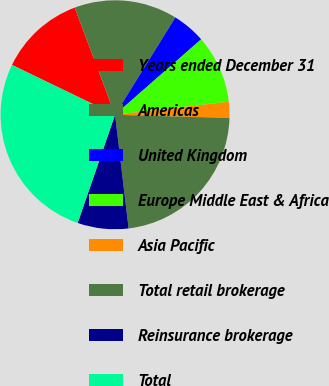Convert chart to OTSL. <chart><loc_0><loc_0><loc_500><loc_500><pie_chart><fcel>Years ended December 31<fcel>Americas<fcel>United Kingdom<fcel>Europe Middle East & Africa<fcel>Asia Pacific<fcel>Total retail brokerage<fcel>Reinsurance brokerage<fcel>Total<nl><fcel>12.1%<fcel>14.56%<fcel>4.72%<fcel>9.64%<fcel>2.26%<fcel>22.66%<fcel>7.18%<fcel>26.87%<nl></chart> 